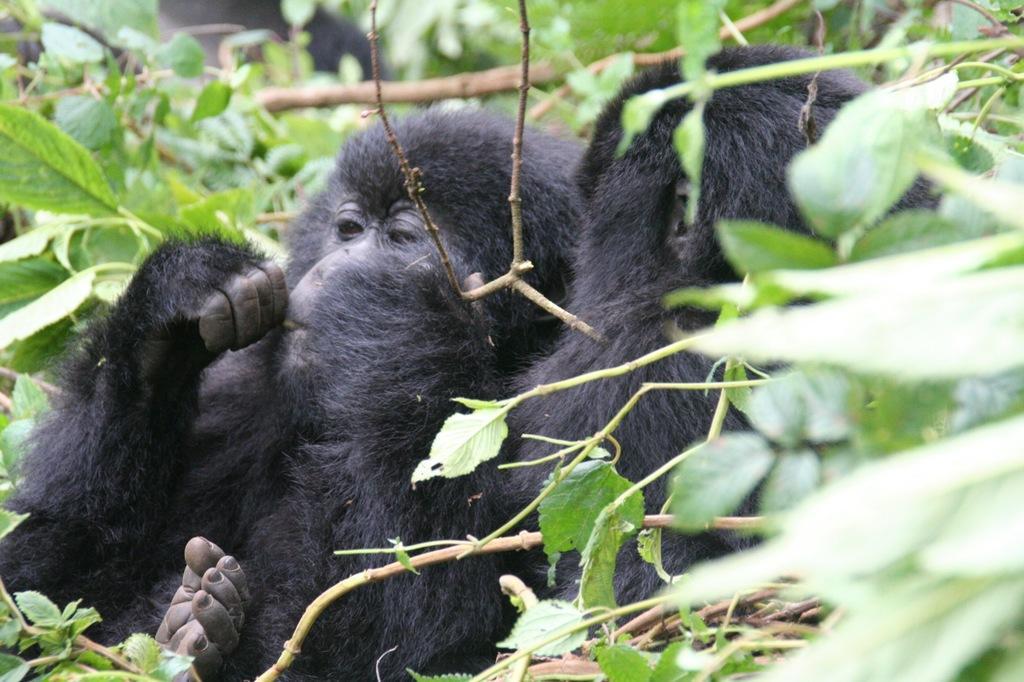Could you give a brief overview of what you see in this image? In this image there are two black monkeys in the middle. There are plants with green leaves around them. 